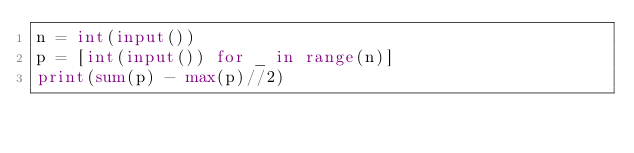Convert code to text. <code><loc_0><loc_0><loc_500><loc_500><_Python_>n = int(input())
p = [int(input()) for _ in range(n)]
print(sum(p) - max(p)//2)
</code> 